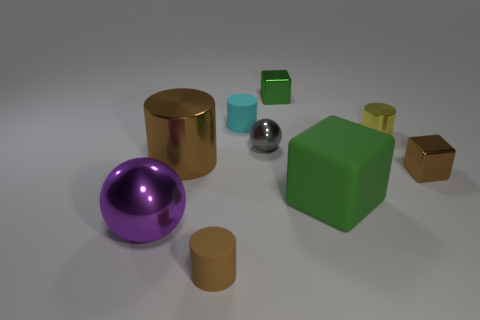How can we categorize the objects in the image based on their materials and properties? The objects in the image appear to have different material properties. The shiny, reflective cylinder and sphere suggest metallic materials, likely with considerable weight. The matte cubes and cylinders might be made of plastic, suggesting a potential for lightness. The purple sphere's reflective surface hints at a smooth glass-like or plastic material, while the matte surfaces could indicate a more porous texture. 